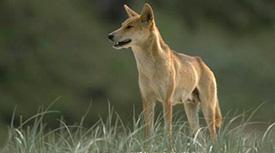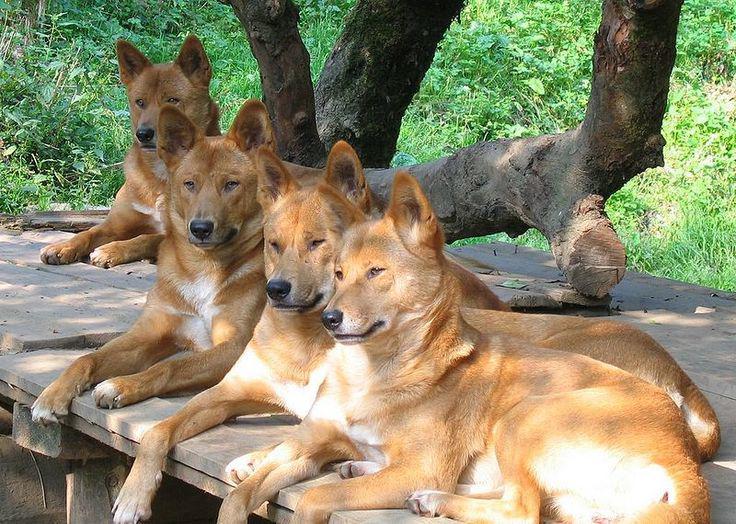The first image is the image on the left, the second image is the image on the right. Given the left and right images, does the statement "The dog in the image on the left is lying with its mouth open." hold true? Answer yes or no. No. The first image is the image on the left, the second image is the image on the right. Analyze the images presented: Is the assertion "An image shows one leftward-gazing wild dog standing in tall grass." valid? Answer yes or no. Yes. 